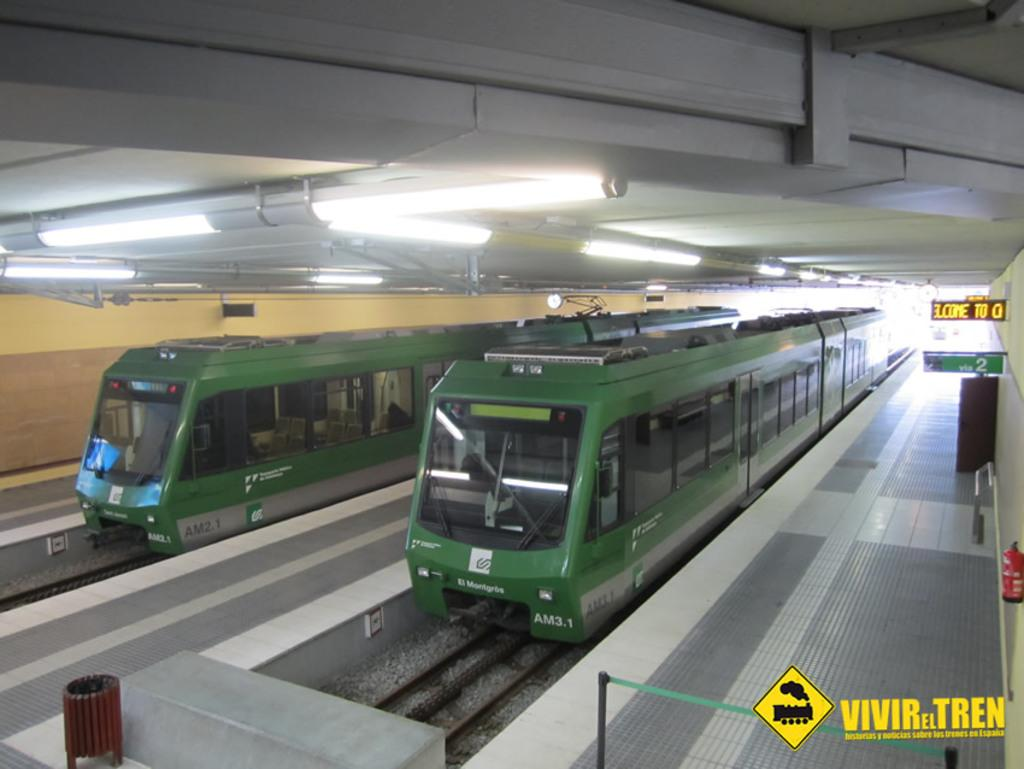What is the main subject of the image? The main subject of the image is trains on the track. Where are the trains located in the image? The trains are on the track in the center of the image. What else can be seen on the right side of the image? There are boards on the right side of the image. What is visible at the top of the image? There are lights visible at the top of the image. What list is being discussed in the image? There is no list present in the image. What does the government have to do with the trains in the image? The image does not depict any government involvement or influence on the trains. 